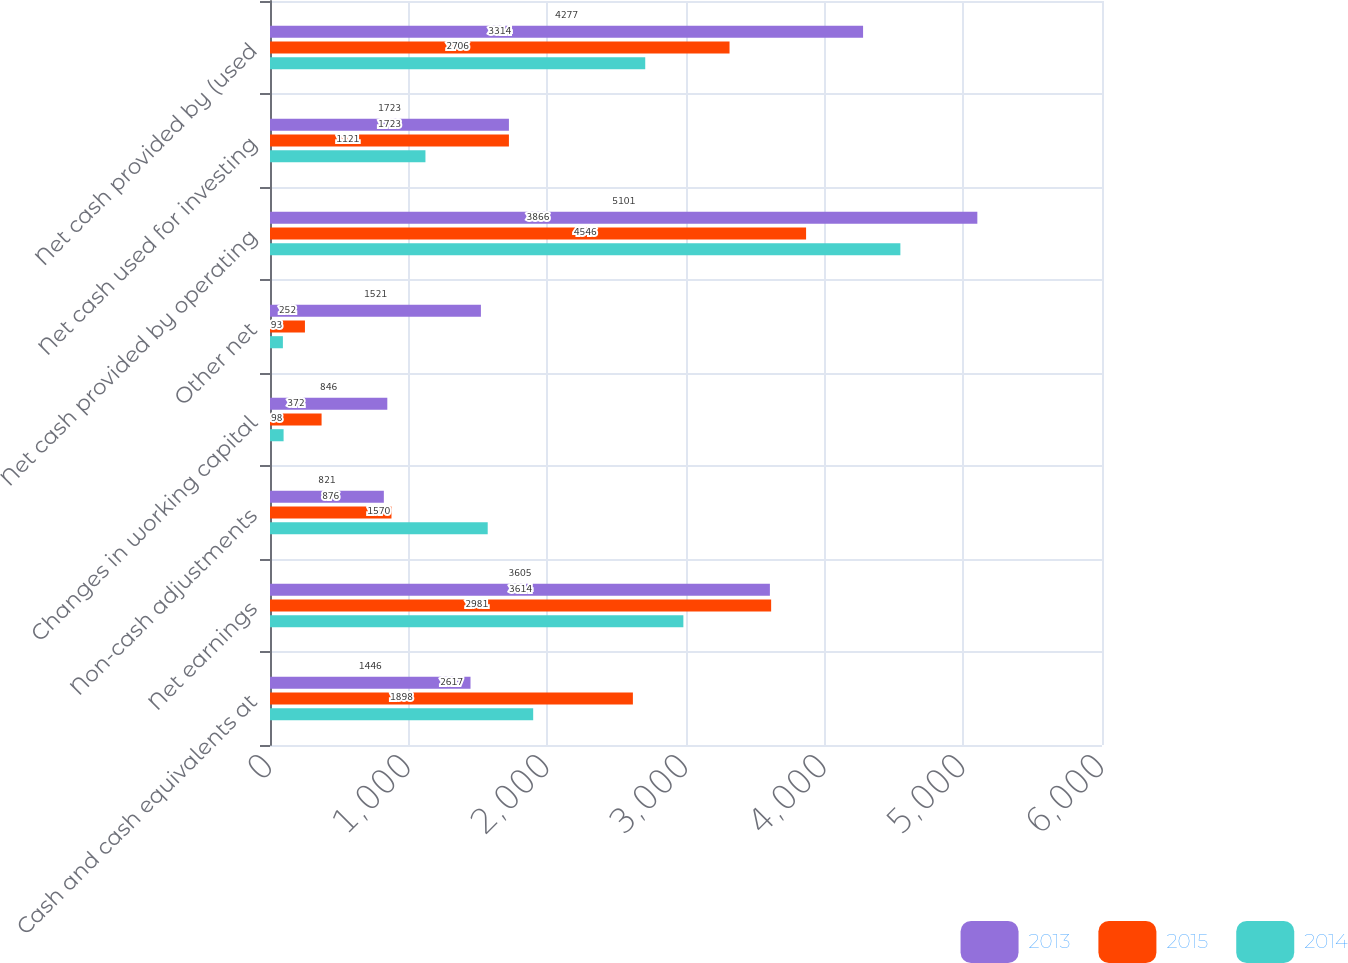<chart> <loc_0><loc_0><loc_500><loc_500><stacked_bar_chart><ecel><fcel>Cash and cash equivalents at<fcel>Net earnings<fcel>Non-cash adjustments<fcel>Changes in working capital<fcel>Other net<fcel>Net cash provided by operating<fcel>Net cash used for investing<fcel>Net cash provided by (used<nl><fcel>2013<fcel>1446<fcel>3605<fcel>821<fcel>846<fcel>1521<fcel>5101<fcel>1723<fcel>4277<nl><fcel>2015<fcel>2617<fcel>3614<fcel>876<fcel>372<fcel>252<fcel>3866<fcel>1723<fcel>3314<nl><fcel>2014<fcel>1898<fcel>2981<fcel>1570<fcel>98<fcel>93<fcel>4546<fcel>1121<fcel>2706<nl></chart> 